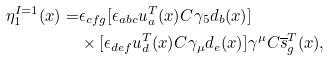Convert formula to latex. <formula><loc_0><loc_0><loc_500><loc_500>\eta ^ { I = 1 } _ { 1 } ( x ) = & \epsilon _ { c f g } [ \epsilon _ { a b c } u ^ { T } _ { a } ( x ) C \gamma _ { 5 } d _ { b } ( x ) ] \\ & \times [ \epsilon _ { d e f } u ^ { T } _ { d } ( x ) C \gamma _ { \mu } d _ { e } ( x ) ] \gamma ^ { \mu } C \overline { s } ^ { T } _ { g } ( x ) ,</formula> 